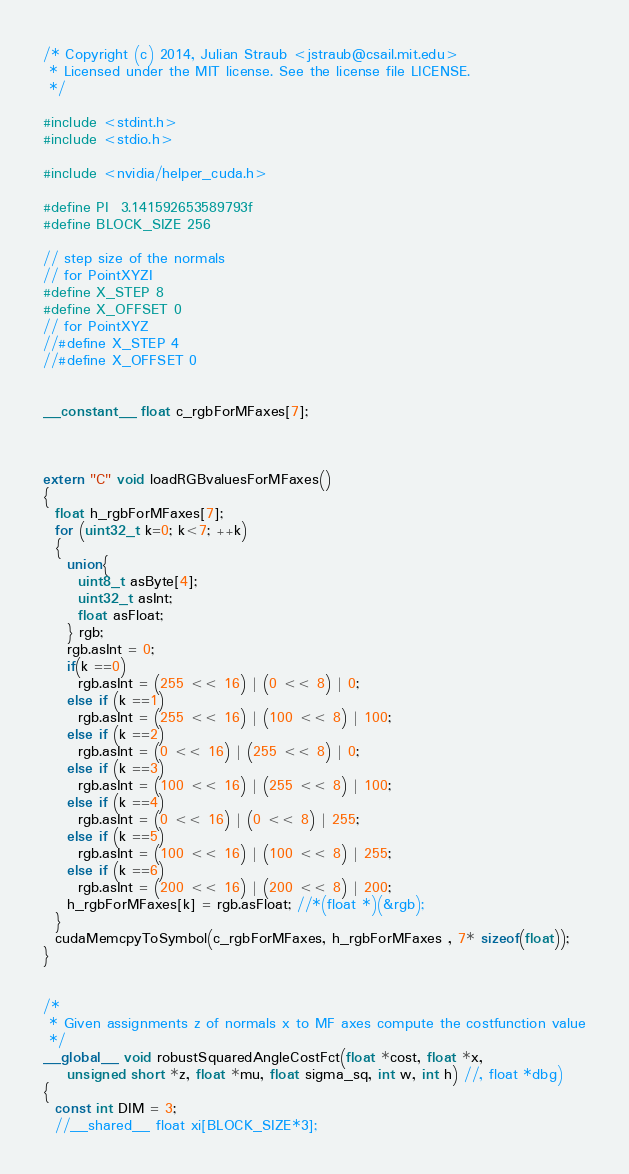Convert code to text. <code><loc_0><loc_0><loc_500><loc_500><_Cuda_>/* Copyright (c) 2014, Julian Straub <jstraub@csail.mit.edu>
 * Licensed under the MIT license. See the license file LICENSE.
 */

#include <stdint.h>
#include <stdio.h>

#include <nvidia/helper_cuda.h>

#define PI  3.141592653589793f
#define BLOCK_SIZE 256

// step size of the normals 
// for PointXYZI
#define X_STEP 8
#define X_OFFSET 0
// for PointXYZ
//#define X_STEP 4
//#define X_OFFSET 0


__constant__ float c_rgbForMFaxes[7];



extern "C" void loadRGBvaluesForMFaxes()
{
  float h_rgbForMFaxes[7];
  for (uint32_t k=0; k<7; ++k)
  {
    union{
      uint8_t asByte[4];
      uint32_t asInt;
      float asFloat;
    } rgb;
    rgb.asInt = 0;
    if(k ==0)
      rgb.asInt = (255 << 16) | (0 << 8) | 0;
    else if (k ==1)
      rgb.asInt = (255 << 16) | (100 << 8) | 100;
    else if (k ==2)
      rgb.asInt = (0 << 16) | (255 << 8) | 0;
    else if (k ==3)
      rgb.asInt = (100 << 16) | (255 << 8) | 100;
    else if (k ==4)
      rgb.asInt = (0 << 16) | (0 << 8) | 255;
    else if (k ==5)
      rgb.asInt = (100 << 16) | (100 << 8) | 255;
    else if (k ==6)
      rgb.asInt = (200 << 16) | (200 << 8) | 200;
    h_rgbForMFaxes[k] = rgb.asFloat; //*(float *)(&rgb);
  }
  cudaMemcpyToSymbol(c_rgbForMFaxes, h_rgbForMFaxes , 7* sizeof(float));
}


/* 
 * Given assignments z of normals x to MF axes compute the costfunction value
 */
__global__ void robustSquaredAngleCostFct(float *cost, float *x, 
    unsigned short *z, float *mu, float sigma_sq, int w, int h) //, float *dbg)
{
  const int DIM = 3;
  //__shared__ float xi[BLOCK_SIZE*3];</code> 